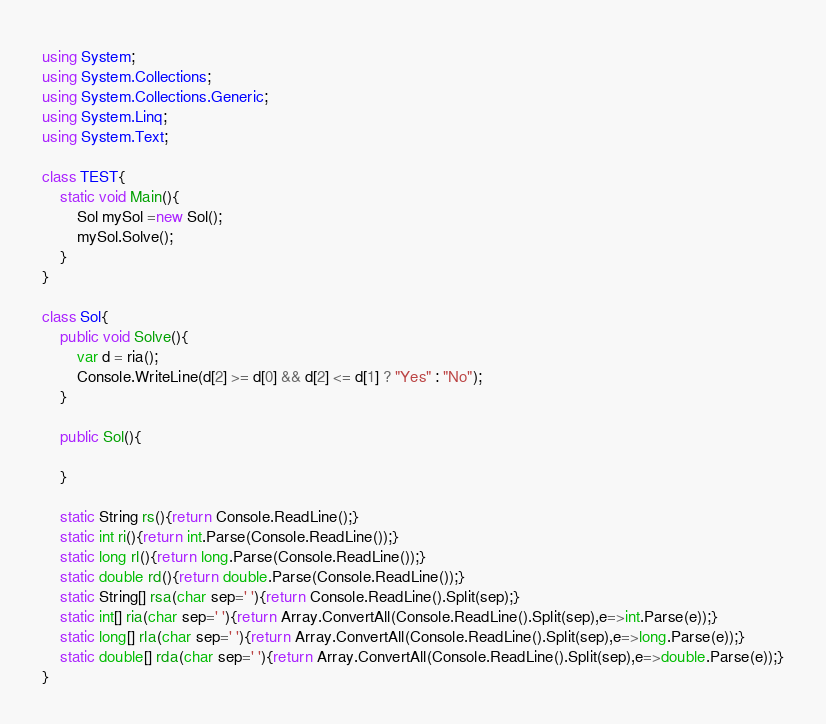<code> <loc_0><loc_0><loc_500><loc_500><_C#_>using System;
using System.Collections;
using System.Collections.Generic;
using System.Linq;
using System.Text;

class TEST{
	static void Main(){
		Sol mySol =new Sol();
		mySol.Solve();
	}
}

class Sol{
	public void Solve(){
		var d = ria();
		Console.WriteLine(d[2] >= d[0] && d[2] <= d[1] ? "Yes" : "No");
	}

	public Sol(){
		
	}

	static String rs(){return Console.ReadLine();}
	static int ri(){return int.Parse(Console.ReadLine());}
	static long rl(){return long.Parse(Console.ReadLine());}
	static double rd(){return double.Parse(Console.ReadLine());}
	static String[] rsa(char sep=' '){return Console.ReadLine().Split(sep);}
	static int[] ria(char sep=' '){return Array.ConvertAll(Console.ReadLine().Split(sep),e=>int.Parse(e));}
	static long[] rla(char sep=' '){return Array.ConvertAll(Console.ReadLine().Split(sep),e=>long.Parse(e));}
	static double[] rda(char sep=' '){return Array.ConvertAll(Console.ReadLine().Split(sep),e=>double.Parse(e));}
}
</code> 